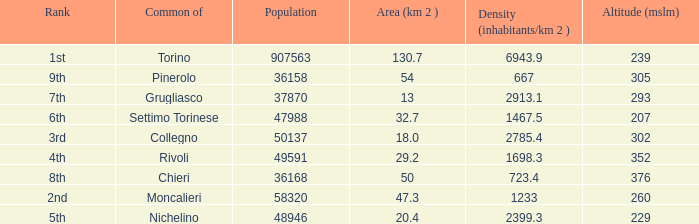The common of Chieri has what population density? 723.4. 